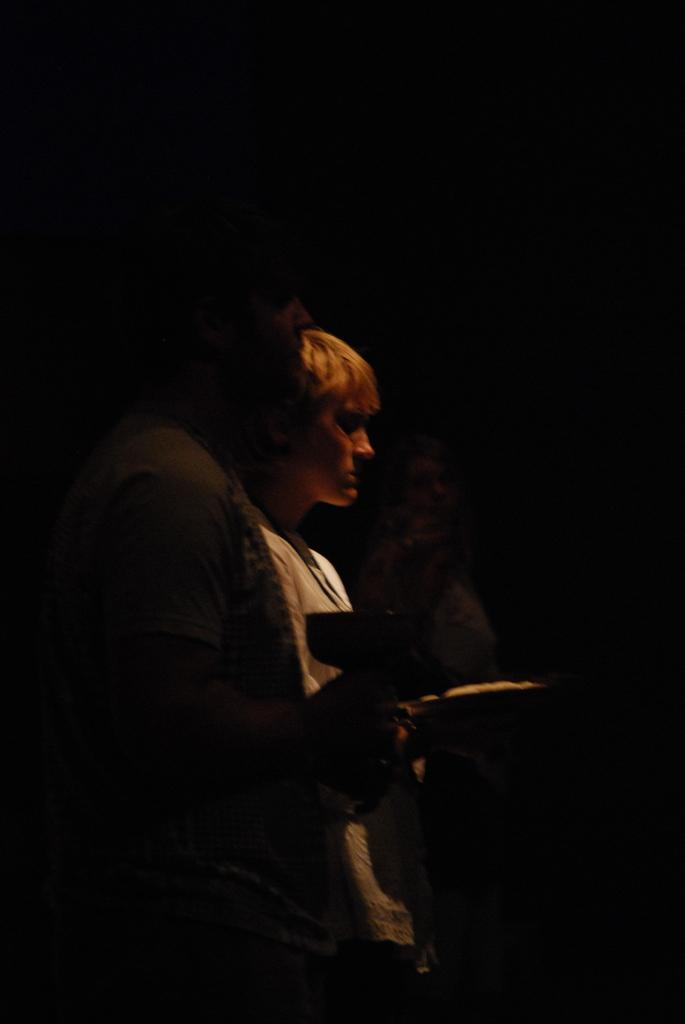How many people are in the image? There is a group of people in the image. What are the people in the image doing? The people are standing. Can you describe any specific actions or interactions among the people? One person is holding an object in their hand. What type of quarter is being discussed by the people in the image? There is no mention of a quarter or any discussion about a quarter in the image. 